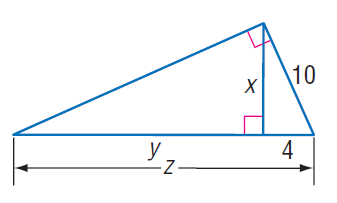Answer the mathemtical geometry problem and directly provide the correct option letter.
Question: Find x.
Choices: A: 6 B: 2 \sqrt { 21 } C: 10 D: 2 \sqrt { 29 } B 